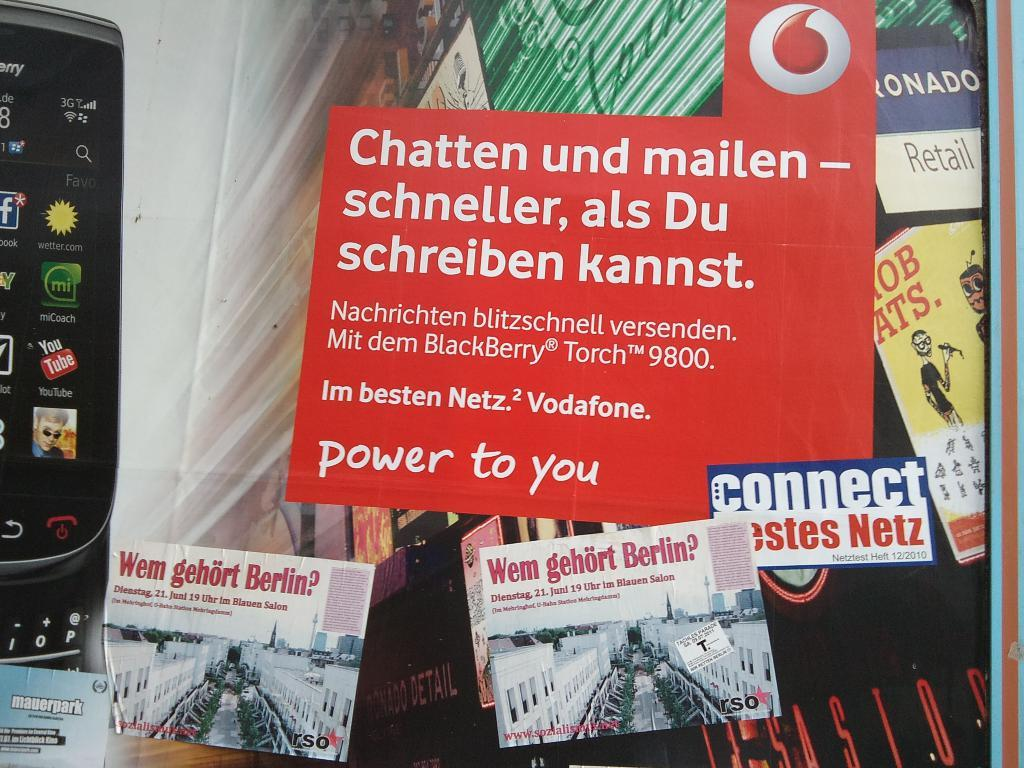<image>
Summarize the visual content of the image. Several different posters on display written in foreign languages. 